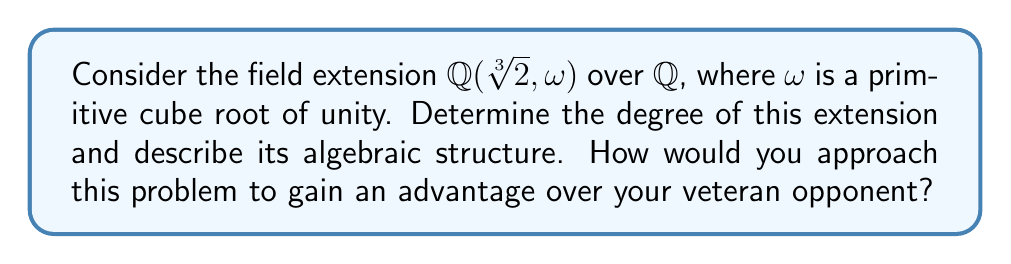Teach me how to tackle this problem. To determine the algebraic structure of this finite field extension, we'll follow these steps:

1) First, let's consider the minimal polynomial of $\sqrt[3]{2}$ over $\mathbb{Q}$:
   $$f(x) = x^3 - 2$$

   This polynomial is irreducible over $\mathbb{Q}$, so $[\mathbb{Q}(\sqrt[3]{2}):\mathbb{Q}] = 3$.

2) Next, consider the minimal polynomial of $\omega$ over $\mathbb{Q}$:
   $$g(x) = x^2 + x + 1$$

   This is irreducible over $\mathbb{Q}$, so $[\mathbb{Q}(\omega):\mathbb{Q}] = 2$.

3) Now, we need to determine if $\sqrt[3]{2}$ and $\omega$ are algebraically independent over $\mathbb{Q}$. They are not, because $\omega$ is not in $\mathbb{R}$, but $\sqrt[3]{2}$ is.

4) To find the degree of the extension, we use the tower law:
   $$[\mathbb{Q}(\sqrt[3]{2}, \omega):\mathbb{Q}] = [\mathbb{Q}(\sqrt[3]{2}, \omega):\mathbb{Q}(\sqrt[3]{2})] \cdot [\mathbb{Q}(\sqrt[3]{2}):\mathbb{Q}]$$

5) $[\mathbb{Q}(\sqrt[3]{2}):\mathbb{Q}] = 3$ from step 1.

6) $[\mathbb{Q}(\sqrt[3]{2}, \omega):\mathbb{Q}(\sqrt[3]{2})]$ is either 1 or 2. It can't be 1 because $\omega \notin \mathbb{Q}(\sqrt[3]{2})$, so it must be 2.

7) Therefore, $[\mathbb{Q}(\sqrt[3]{2}, \omega):\mathbb{Q}] = 2 \cdot 3 = 6$.

8) The algebraic structure is a simple extension of degree 6 over $\mathbb{Q}$. It can be generated by a single element $\alpha = \sqrt[3]{2} + \omega$.

To gain an advantage, focus on efficiently identifying the relationships between the elements and using the tower law to simplify the problem.
Answer: Degree 6 simple extension over $\mathbb{Q}$, generated by $\alpha = \sqrt[3]{2} + \omega$ 